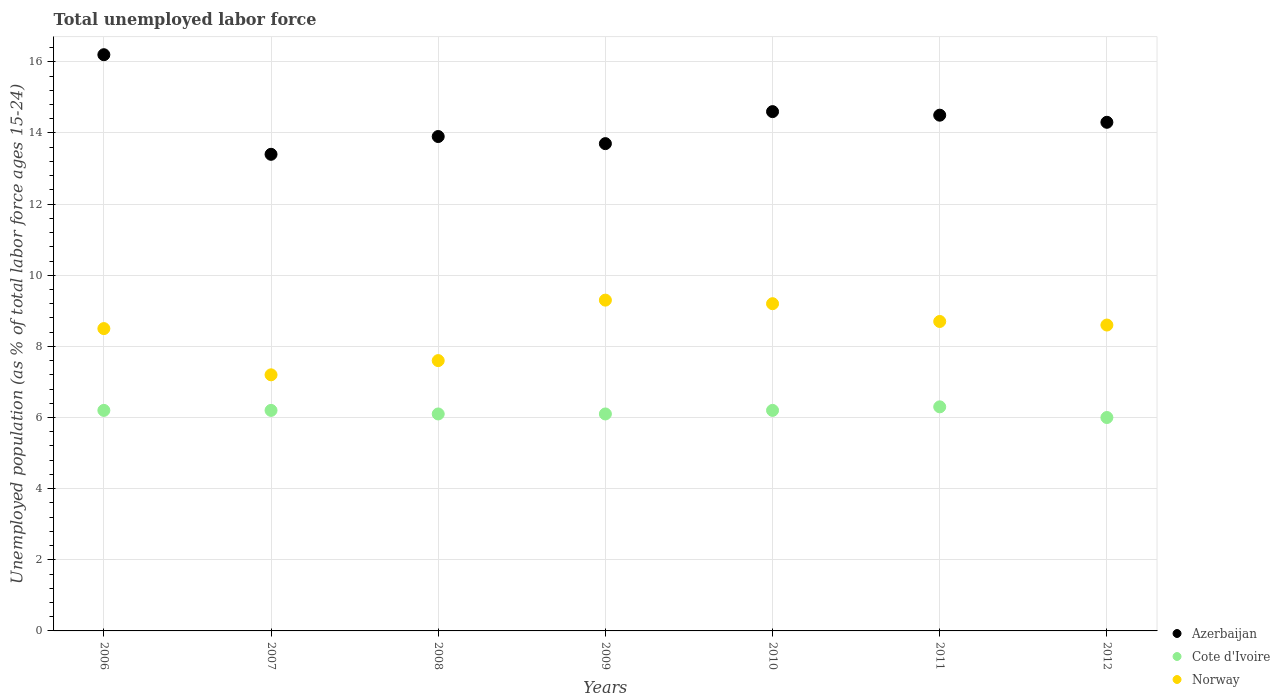Is the number of dotlines equal to the number of legend labels?
Ensure brevity in your answer.  Yes. What is the percentage of unemployed population in in Azerbaijan in 2010?
Give a very brief answer. 14.6. Across all years, what is the maximum percentage of unemployed population in in Azerbaijan?
Offer a very short reply. 16.2. Across all years, what is the minimum percentage of unemployed population in in Norway?
Ensure brevity in your answer.  7.2. In which year was the percentage of unemployed population in in Norway maximum?
Offer a very short reply. 2009. What is the total percentage of unemployed population in in Azerbaijan in the graph?
Provide a succinct answer. 100.6. What is the difference between the percentage of unemployed population in in Cote d'Ivoire in 2006 and that in 2007?
Your response must be concise. 0. What is the difference between the percentage of unemployed population in in Azerbaijan in 2011 and the percentage of unemployed population in in Norway in 2008?
Your answer should be very brief. 6.9. What is the average percentage of unemployed population in in Azerbaijan per year?
Your answer should be very brief. 14.37. In the year 2012, what is the difference between the percentage of unemployed population in in Cote d'Ivoire and percentage of unemployed population in in Norway?
Offer a terse response. -2.6. In how many years, is the percentage of unemployed population in in Norway greater than 8 %?
Provide a succinct answer. 5. What is the ratio of the percentage of unemployed population in in Cote d'Ivoire in 2007 to that in 2008?
Offer a terse response. 1.02. What is the difference between the highest and the second highest percentage of unemployed population in in Norway?
Provide a succinct answer. 0.1. What is the difference between the highest and the lowest percentage of unemployed population in in Norway?
Your answer should be very brief. 2.1. In how many years, is the percentage of unemployed population in in Norway greater than the average percentage of unemployed population in in Norway taken over all years?
Offer a very short reply. 5. How many years are there in the graph?
Provide a succinct answer. 7. What is the difference between two consecutive major ticks on the Y-axis?
Ensure brevity in your answer.  2. Are the values on the major ticks of Y-axis written in scientific E-notation?
Keep it short and to the point. No. Does the graph contain grids?
Make the answer very short. Yes. How are the legend labels stacked?
Give a very brief answer. Vertical. What is the title of the graph?
Your answer should be compact. Total unemployed labor force. What is the label or title of the Y-axis?
Give a very brief answer. Unemployed population (as % of total labor force ages 15-24). What is the Unemployed population (as % of total labor force ages 15-24) of Azerbaijan in 2006?
Your answer should be very brief. 16.2. What is the Unemployed population (as % of total labor force ages 15-24) in Cote d'Ivoire in 2006?
Offer a very short reply. 6.2. What is the Unemployed population (as % of total labor force ages 15-24) of Azerbaijan in 2007?
Provide a short and direct response. 13.4. What is the Unemployed population (as % of total labor force ages 15-24) of Cote d'Ivoire in 2007?
Provide a succinct answer. 6.2. What is the Unemployed population (as % of total labor force ages 15-24) in Norway in 2007?
Offer a terse response. 7.2. What is the Unemployed population (as % of total labor force ages 15-24) of Azerbaijan in 2008?
Make the answer very short. 13.9. What is the Unemployed population (as % of total labor force ages 15-24) in Cote d'Ivoire in 2008?
Ensure brevity in your answer.  6.1. What is the Unemployed population (as % of total labor force ages 15-24) of Norway in 2008?
Your answer should be compact. 7.6. What is the Unemployed population (as % of total labor force ages 15-24) of Azerbaijan in 2009?
Keep it short and to the point. 13.7. What is the Unemployed population (as % of total labor force ages 15-24) of Cote d'Ivoire in 2009?
Keep it short and to the point. 6.1. What is the Unemployed population (as % of total labor force ages 15-24) in Norway in 2009?
Make the answer very short. 9.3. What is the Unemployed population (as % of total labor force ages 15-24) in Azerbaijan in 2010?
Offer a very short reply. 14.6. What is the Unemployed population (as % of total labor force ages 15-24) of Cote d'Ivoire in 2010?
Keep it short and to the point. 6.2. What is the Unemployed population (as % of total labor force ages 15-24) in Norway in 2010?
Offer a very short reply. 9.2. What is the Unemployed population (as % of total labor force ages 15-24) in Azerbaijan in 2011?
Offer a very short reply. 14.5. What is the Unemployed population (as % of total labor force ages 15-24) in Cote d'Ivoire in 2011?
Your answer should be very brief. 6.3. What is the Unemployed population (as % of total labor force ages 15-24) in Norway in 2011?
Offer a terse response. 8.7. What is the Unemployed population (as % of total labor force ages 15-24) of Azerbaijan in 2012?
Ensure brevity in your answer.  14.3. What is the Unemployed population (as % of total labor force ages 15-24) of Norway in 2012?
Give a very brief answer. 8.6. Across all years, what is the maximum Unemployed population (as % of total labor force ages 15-24) in Azerbaijan?
Give a very brief answer. 16.2. Across all years, what is the maximum Unemployed population (as % of total labor force ages 15-24) of Cote d'Ivoire?
Your answer should be compact. 6.3. Across all years, what is the maximum Unemployed population (as % of total labor force ages 15-24) in Norway?
Your answer should be compact. 9.3. Across all years, what is the minimum Unemployed population (as % of total labor force ages 15-24) in Azerbaijan?
Offer a very short reply. 13.4. Across all years, what is the minimum Unemployed population (as % of total labor force ages 15-24) of Norway?
Make the answer very short. 7.2. What is the total Unemployed population (as % of total labor force ages 15-24) in Azerbaijan in the graph?
Give a very brief answer. 100.6. What is the total Unemployed population (as % of total labor force ages 15-24) in Cote d'Ivoire in the graph?
Offer a very short reply. 43.1. What is the total Unemployed population (as % of total labor force ages 15-24) in Norway in the graph?
Your response must be concise. 59.1. What is the difference between the Unemployed population (as % of total labor force ages 15-24) in Azerbaijan in 2006 and that in 2007?
Give a very brief answer. 2.8. What is the difference between the Unemployed population (as % of total labor force ages 15-24) in Cote d'Ivoire in 2006 and that in 2007?
Ensure brevity in your answer.  0. What is the difference between the Unemployed population (as % of total labor force ages 15-24) in Norway in 2006 and that in 2007?
Your answer should be compact. 1.3. What is the difference between the Unemployed population (as % of total labor force ages 15-24) of Norway in 2006 and that in 2008?
Provide a succinct answer. 0.9. What is the difference between the Unemployed population (as % of total labor force ages 15-24) of Norway in 2006 and that in 2009?
Give a very brief answer. -0.8. What is the difference between the Unemployed population (as % of total labor force ages 15-24) of Cote d'Ivoire in 2006 and that in 2010?
Offer a very short reply. 0. What is the difference between the Unemployed population (as % of total labor force ages 15-24) in Azerbaijan in 2006 and that in 2012?
Your answer should be very brief. 1.9. What is the difference between the Unemployed population (as % of total labor force ages 15-24) of Cote d'Ivoire in 2006 and that in 2012?
Your answer should be compact. 0.2. What is the difference between the Unemployed population (as % of total labor force ages 15-24) in Norway in 2007 and that in 2008?
Provide a short and direct response. -0.4. What is the difference between the Unemployed population (as % of total labor force ages 15-24) in Azerbaijan in 2007 and that in 2009?
Offer a terse response. -0.3. What is the difference between the Unemployed population (as % of total labor force ages 15-24) of Azerbaijan in 2007 and that in 2010?
Ensure brevity in your answer.  -1.2. What is the difference between the Unemployed population (as % of total labor force ages 15-24) of Cote d'Ivoire in 2007 and that in 2010?
Your response must be concise. 0. What is the difference between the Unemployed population (as % of total labor force ages 15-24) in Norway in 2007 and that in 2010?
Offer a terse response. -2. What is the difference between the Unemployed population (as % of total labor force ages 15-24) of Azerbaijan in 2007 and that in 2012?
Your answer should be very brief. -0.9. What is the difference between the Unemployed population (as % of total labor force ages 15-24) of Cote d'Ivoire in 2008 and that in 2009?
Your response must be concise. 0. What is the difference between the Unemployed population (as % of total labor force ages 15-24) of Norway in 2008 and that in 2009?
Offer a very short reply. -1.7. What is the difference between the Unemployed population (as % of total labor force ages 15-24) in Azerbaijan in 2008 and that in 2010?
Your response must be concise. -0.7. What is the difference between the Unemployed population (as % of total labor force ages 15-24) of Norway in 2008 and that in 2010?
Ensure brevity in your answer.  -1.6. What is the difference between the Unemployed population (as % of total labor force ages 15-24) in Cote d'Ivoire in 2008 and that in 2011?
Give a very brief answer. -0.2. What is the difference between the Unemployed population (as % of total labor force ages 15-24) in Azerbaijan in 2008 and that in 2012?
Keep it short and to the point. -0.4. What is the difference between the Unemployed population (as % of total labor force ages 15-24) of Norway in 2008 and that in 2012?
Provide a short and direct response. -1. What is the difference between the Unemployed population (as % of total labor force ages 15-24) in Cote d'Ivoire in 2009 and that in 2010?
Provide a succinct answer. -0.1. What is the difference between the Unemployed population (as % of total labor force ages 15-24) in Norway in 2009 and that in 2010?
Make the answer very short. 0.1. What is the difference between the Unemployed population (as % of total labor force ages 15-24) of Cote d'Ivoire in 2009 and that in 2011?
Make the answer very short. -0.2. What is the difference between the Unemployed population (as % of total labor force ages 15-24) of Norway in 2009 and that in 2011?
Offer a very short reply. 0.6. What is the difference between the Unemployed population (as % of total labor force ages 15-24) in Cote d'Ivoire in 2010 and that in 2011?
Your response must be concise. -0.1. What is the difference between the Unemployed population (as % of total labor force ages 15-24) of Norway in 2010 and that in 2011?
Give a very brief answer. 0.5. What is the difference between the Unemployed population (as % of total labor force ages 15-24) of Cote d'Ivoire in 2010 and that in 2012?
Ensure brevity in your answer.  0.2. What is the difference between the Unemployed population (as % of total labor force ages 15-24) in Norway in 2010 and that in 2012?
Keep it short and to the point. 0.6. What is the difference between the Unemployed population (as % of total labor force ages 15-24) in Cote d'Ivoire in 2011 and that in 2012?
Provide a succinct answer. 0.3. What is the difference between the Unemployed population (as % of total labor force ages 15-24) in Azerbaijan in 2006 and the Unemployed population (as % of total labor force ages 15-24) in Cote d'Ivoire in 2007?
Your answer should be very brief. 10. What is the difference between the Unemployed population (as % of total labor force ages 15-24) of Cote d'Ivoire in 2006 and the Unemployed population (as % of total labor force ages 15-24) of Norway in 2007?
Your answer should be compact. -1. What is the difference between the Unemployed population (as % of total labor force ages 15-24) in Azerbaijan in 2006 and the Unemployed population (as % of total labor force ages 15-24) in Cote d'Ivoire in 2008?
Your answer should be compact. 10.1. What is the difference between the Unemployed population (as % of total labor force ages 15-24) of Azerbaijan in 2006 and the Unemployed population (as % of total labor force ages 15-24) of Norway in 2008?
Your response must be concise. 8.6. What is the difference between the Unemployed population (as % of total labor force ages 15-24) of Cote d'Ivoire in 2006 and the Unemployed population (as % of total labor force ages 15-24) of Norway in 2008?
Give a very brief answer. -1.4. What is the difference between the Unemployed population (as % of total labor force ages 15-24) in Azerbaijan in 2006 and the Unemployed population (as % of total labor force ages 15-24) in Cote d'Ivoire in 2009?
Your answer should be compact. 10.1. What is the difference between the Unemployed population (as % of total labor force ages 15-24) of Azerbaijan in 2006 and the Unemployed population (as % of total labor force ages 15-24) of Norway in 2009?
Keep it short and to the point. 6.9. What is the difference between the Unemployed population (as % of total labor force ages 15-24) in Cote d'Ivoire in 2006 and the Unemployed population (as % of total labor force ages 15-24) in Norway in 2009?
Provide a short and direct response. -3.1. What is the difference between the Unemployed population (as % of total labor force ages 15-24) in Azerbaijan in 2006 and the Unemployed population (as % of total labor force ages 15-24) in Cote d'Ivoire in 2010?
Ensure brevity in your answer.  10. What is the difference between the Unemployed population (as % of total labor force ages 15-24) of Azerbaijan in 2006 and the Unemployed population (as % of total labor force ages 15-24) of Norway in 2011?
Your answer should be compact. 7.5. What is the difference between the Unemployed population (as % of total labor force ages 15-24) in Azerbaijan in 2006 and the Unemployed population (as % of total labor force ages 15-24) in Norway in 2012?
Make the answer very short. 7.6. What is the difference between the Unemployed population (as % of total labor force ages 15-24) in Azerbaijan in 2007 and the Unemployed population (as % of total labor force ages 15-24) in Cote d'Ivoire in 2008?
Make the answer very short. 7.3. What is the difference between the Unemployed population (as % of total labor force ages 15-24) in Cote d'Ivoire in 2007 and the Unemployed population (as % of total labor force ages 15-24) in Norway in 2008?
Provide a succinct answer. -1.4. What is the difference between the Unemployed population (as % of total labor force ages 15-24) in Azerbaijan in 2007 and the Unemployed population (as % of total labor force ages 15-24) in Cote d'Ivoire in 2009?
Your response must be concise. 7.3. What is the difference between the Unemployed population (as % of total labor force ages 15-24) of Azerbaijan in 2007 and the Unemployed population (as % of total labor force ages 15-24) of Norway in 2010?
Your answer should be very brief. 4.2. What is the difference between the Unemployed population (as % of total labor force ages 15-24) of Cote d'Ivoire in 2007 and the Unemployed population (as % of total labor force ages 15-24) of Norway in 2011?
Keep it short and to the point. -2.5. What is the difference between the Unemployed population (as % of total labor force ages 15-24) of Azerbaijan in 2007 and the Unemployed population (as % of total labor force ages 15-24) of Norway in 2012?
Provide a succinct answer. 4.8. What is the difference between the Unemployed population (as % of total labor force ages 15-24) of Azerbaijan in 2008 and the Unemployed population (as % of total labor force ages 15-24) of Cote d'Ivoire in 2009?
Your answer should be very brief. 7.8. What is the difference between the Unemployed population (as % of total labor force ages 15-24) in Azerbaijan in 2008 and the Unemployed population (as % of total labor force ages 15-24) in Norway in 2009?
Keep it short and to the point. 4.6. What is the difference between the Unemployed population (as % of total labor force ages 15-24) in Azerbaijan in 2008 and the Unemployed population (as % of total labor force ages 15-24) in Norway in 2010?
Offer a terse response. 4.7. What is the difference between the Unemployed population (as % of total labor force ages 15-24) in Cote d'Ivoire in 2008 and the Unemployed population (as % of total labor force ages 15-24) in Norway in 2011?
Offer a very short reply. -2.6. What is the difference between the Unemployed population (as % of total labor force ages 15-24) in Cote d'Ivoire in 2008 and the Unemployed population (as % of total labor force ages 15-24) in Norway in 2012?
Offer a very short reply. -2.5. What is the difference between the Unemployed population (as % of total labor force ages 15-24) in Cote d'Ivoire in 2009 and the Unemployed population (as % of total labor force ages 15-24) in Norway in 2010?
Make the answer very short. -3.1. What is the difference between the Unemployed population (as % of total labor force ages 15-24) of Azerbaijan in 2009 and the Unemployed population (as % of total labor force ages 15-24) of Norway in 2011?
Offer a very short reply. 5. What is the difference between the Unemployed population (as % of total labor force ages 15-24) in Cote d'Ivoire in 2009 and the Unemployed population (as % of total labor force ages 15-24) in Norway in 2011?
Your response must be concise. -2.6. What is the difference between the Unemployed population (as % of total labor force ages 15-24) of Azerbaijan in 2009 and the Unemployed population (as % of total labor force ages 15-24) of Cote d'Ivoire in 2012?
Provide a short and direct response. 7.7. What is the difference between the Unemployed population (as % of total labor force ages 15-24) of Cote d'Ivoire in 2010 and the Unemployed population (as % of total labor force ages 15-24) of Norway in 2012?
Provide a succinct answer. -2.4. What is the difference between the Unemployed population (as % of total labor force ages 15-24) in Azerbaijan in 2011 and the Unemployed population (as % of total labor force ages 15-24) in Cote d'Ivoire in 2012?
Keep it short and to the point. 8.5. What is the average Unemployed population (as % of total labor force ages 15-24) in Azerbaijan per year?
Ensure brevity in your answer.  14.37. What is the average Unemployed population (as % of total labor force ages 15-24) of Cote d'Ivoire per year?
Your response must be concise. 6.16. What is the average Unemployed population (as % of total labor force ages 15-24) in Norway per year?
Provide a short and direct response. 8.44. In the year 2006, what is the difference between the Unemployed population (as % of total labor force ages 15-24) of Azerbaijan and Unemployed population (as % of total labor force ages 15-24) of Cote d'Ivoire?
Your answer should be compact. 10. In the year 2006, what is the difference between the Unemployed population (as % of total labor force ages 15-24) of Cote d'Ivoire and Unemployed population (as % of total labor force ages 15-24) of Norway?
Your answer should be very brief. -2.3. In the year 2007, what is the difference between the Unemployed population (as % of total labor force ages 15-24) in Azerbaijan and Unemployed population (as % of total labor force ages 15-24) in Norway?
Provide a succinct answer. 6.2. In the year 2007, what is the difference between the Unemployed population (as % of total labor force ages 15-24) in Cote d'Ivoire and Unemployed population (as % of total labor force ages 15-24) in Norway?
Your response must be concise. -1. In the year 2009, what is the difference between the Unemployed population (as % of total labor force ages 15-24) of Azerbaijan and Unemployed population (as % of total labor force ages 15-24) of Cote d'Ivoire?
Give a very brief answer. 7.6. In the year 2009, what is the difference between the Unemployed population (as % of total labor force ages 15-24) of Azerbaijan and Unemployed population (as % of total labor force ages 15-24) of Norway?
Your answer should be very brief. 4.4. In the year 2010, what is the difference between the Unemployed population (as % of total labor force ages 15-24) of Azerbaijan and Unemployed population (as % of total labor force ages 15-24) of Cote d'Ivoire?
Give a very brief answer. 8.4. In the year 2010, what is the difference between the Unemployed population (as % of total labor force ages 15-24) of Azerbaijan and Unemployed population (as % of total labor force ages 15-24) of Norway?
Offer a terse response. 5.4. In the year 2011, what is the difference between the Unemployed population (as % of total labor force ages 15-24) in Azerbaijan and Unemployed population (as % of total labor force ages 15-24) in Cote d'Ivoire?
Give a very brief answer. 8.2. In the year 2011, what is the difference between the Unemployed population (as % of total labor force ages 15-24) in Azerbaijan and Unemployed population (as % of total labor force ages 15-24) in Norway?
Keep it short and to the point. 5.8. In the year 2011, what is the difference between the Unemployed population (as % of total labor force ages 15-24) in Cote d'Ivoire and Unemployed population (as % of total labor force ages 15-24) in Norway?
Your answer should be very brief. -2.4. In the year 2012, what is the difference between the Unemployed population (as % of total labor force ages 15-24) of Azerbaijan and Unemployed population (as % of total labor force ages 15-24) of Norway?
Your response must be concise. 5.7. In the year 2012, what is the difference between the Unemployed population (as % of total labor force ages 15-24) of Cote d'Ivoire and Unemployed population (as % of total labor force ages 15-24) of Norway?
Offer a terse response. -2.6. What is the ratio of the Unemployed population (as % of total labor force ages 15-24) of Azerbaijan in 2006 to that in 2007?
Make the answer very short. 1.21. What is the ratio of the Unemployed population (as % of total labor force ages 15-24) of Cote d'Ivoire in 2006 to that in 2007?
Offer a terse response. 1. What is the ratio of the Unemployed population (as % of total labor force ages 15-24) of Norway in 2006 to that in 2007?
Ensure brevity in your answer.  1.18. What is the ratio of the Unemployed population (as % of total labor force ages 15-24) of Azerbaijan in 2006 to that in 2008?
Offer a terse response. 1.17. What is the ratio of the Unemployed population (as % of total labor force ages 15-24) in Cote d'Ivoire in 2006 to that in 2008?
Offer a very short reply. 1.02. What is the ratio of the Unemployed population (as % of total labor force ages 15-24) of Norway in 2006 to that in 2008?
Make the answer very short. 1.12. What is the ratio of the Unemployed population (as % of total labor force ages 15-24) in Azerbaijan in 2006 to that in 2009?
Make the answer very short. 1.18. What is the ratio of the Unemployed population (as % of total labor force ages 15-24) in Cote d'Ivoire in 2006 to that in 2009?
Your answer should be very brief. 1.02. What is the ratio of the Unemployed population (as % of total labor force ages 15-24) in Norway in 2006 to that in 2009?
Provide a short and direct response. 0.91. What is the ratio of the Unemployed population (as % of total labor force ages 15-24) of Azerbaijan in 2006 to that in 2010?
Offer a very short reply. 1.11. What is the ratio of the Unemployed population (as % of total labor force ages 15-24) of Norway in 2006 to that in 2010?
Ensure brevity in your answer.  0.92. What is the ratio of the Unemployed population (as % of total labor force ages 15-24) in Azerbaijan in 2006 to that in 2011?
Your answer should be very brief. 1.12. What is the ratio of the Unemployed population (as % of total labor force ages 15-24) of Cote d'Ivoire in 2006 to that in 2011?
Give a very brief answer. 0.98. What is the ratio of the Unemployed population (as % of total labor force ages 15-24) in Norway in 2006 to that in 2011?
Your answer should be compact. 0.98. What is the ratio of the Unemployed population (as % of total labor force ages 15-24) of Azerbaijan in 2006 to that in 2012?
Keep it short and to the point. 1.13. What is the ratio of the Unemployed population (as % of total labor force ages 15-24) in Cote d'Ivoire in 2006 to that in 2012?
Provide a short and direct response. 1.03. What is the ratio of the Unemployed population (as % of total labor force ages 15-24) in Norway in 2006 to that in 2012?
Provide a succinct answer. 0.99. What is the ratio of the Unemployed population (as % of total labor force ages 15-24) in Cote d'Ivoire in 2007 to that in 2008?
Your response must be concise. 1.02. What is the ratio of the Unemployed population (as % of total labor force ages 15-24) of Azerbaijan in 2007 to that in 2009?
Offer a terse response. 0.98. What is the ratio of the Unemployed population (as % of total labor force ages 15-24) in Cote d'Ivoire in 2007 to that in 2009?
Ensure brevity in your answer.  1.02. What is the ratio of the Unemployed population (as % of total labor force ages 15-24) in Norway in 2007 to that in 2009?
Ensure brevity in your answer.  0.77. What is the ratio of the Unemployed population (as % of total labor force ages 15-24) of Azerbaijan in 2007 to that in 2010?
Give a very brief answer. 0.92. What is the ratio of the Unemployed population (as % of total labor force ages 15-24) of Cote d'Ivoire in 2007 to that in 2010?
Offer a very short reply. 1. What is the ratio of the Unemployed population (as % of total labor force ages 15-24) in Norway in 2007 to that in 2010?
Keep it short and to the point. 0.78. What is the ratio of the Unemployed population (as % of total labor force ages 15-24) in Azerbaijan in 2007 to that in 2011?
Your response must be concise. 0.92. What is the ratio of the Unemployed population (as % of total labor force ages 15-24) in Cote d'Ivoire in 2007 to that in 2011?
Provide a short and direct response. 0.98. What is the ratio of the Unemployed population (as % of total labor force ages 15-24) in Norway in 2007 to that in 2011?
Provide a succinct answer. 0.83. What is the ratio of the Unemployed population (as % of total labor force ages 15-24) in Azerbaijan in 2007 to that in 2012?
Offer a very short reply. 0.94. What is the ratio of the Unemployed population (as % of total labor force ages 15-24) in Norway in 2007 to that in 2012?
Your response must be concise. 0.84. What is the ratio of the Unemployed population (as % of total labor force ages 15-24) of Azerbaijan in 2008 to that in 2009?
Make the answer very short. 1.01. What is the ratio of the Unemployed population (as % of total labor force ages 15-24) in Cote d'Ivoire in 2008 to that in 2009?
Provide a short and direct response. 1. What is the ratio of the Unemployed population (as % of total labor force ages 15-24) of Norway in 2008 to that in 2009?
Keep it short and to the point. 0.82. What is the ratio of the Unemployed population (as % of total labor force ages 15-24) of Azerbaijan in 2008 to that in 2010?
Provide a short and direct response. 0.95. What is the ratio of the Unemployed population (as % of total labor force ages 15-24) in Cote d'Ivoire in 2008 to that in 2010?
Ensure brevity in your answer.  0.98. What is the ratio of the Unemployed population (as % of total labor force ages 15-24) in Norway in 2008 to that in 2010?
Your answer should be very brief. 0.83. What is the ratio of the Unemployed population (as % of total labor force ages 15-24) of Azerbaijan in 2008 to that in 2011?
Offer a very short reply. 0.96. What is the ratio of the Unemployed population (as % of total labor force ages 15-24) in Cote d'Ivoire in 2008 to that in 2011?
Provide a short and direct response. 0.97. What is the ratio of the Unemployed population (as % of total labor force ages 15-24) of Norway in 2008 to that in 2011?
Your answer should be compact. 0.87. What is the ratio of the Unemployed population (as % of total labor force ages 15-24) in Cote d'Ivoire in 2008 to that in 2012?
Your answer should be compact. 1.02. What is the ratio of the Unemployed population (as % of total labor force ages 15-24) in Norway in 2008 to that in 2012?
Provide a short and direct response. 0.88. What is the ratio of the Unemployed population (as % of total labor force ages 15-24) in Azerbaijan in 2009 to that in 2010?
Keep it short and to the point. 0.94. What is the ratio of the Unemployed population (as % of total labor force ages 15-24) of Cote d'Ivoire in 2009 to that in 2010?
Your answer should be very brief. 0.98. What is the ratio of the Unemployed population (as % of total labor force ages 15-24) of Norway in 2009 to that in 2010?
Your response must be concise. 1.01. What is the ratio of the Unemployed population (as % of total labor force ages 15-24) of Azerbaijan in 2009 to that in 2011?
Your response must be concise. 0.94. What is the ratio of the Unemployed population (as % of total labor force ages 15-24) in Cote d'Ivoire in 2009 to that in 2011?
Ensure brevity in your answer.  0.97. What is the ratio of the Unemployed population (as % of total labor force ages 15-24) of Norway in 2009 to that in 2011?
Ensure brevity in your answer.  1.07. What is the ratio of the Unemployed population (as % of total labor force ages 15-24) in Azerbaijan in 2009 to that in 2012?
Provide a short and direct response. 0.96. What is the ratio of the Unemployed population (as % of total labor force ages 15-24) in Cote d'Ivoire in 2009 to that in 2012?
Offer a terse response. 1.02. What is the ratio of the Unemployed population (as % of total labor force ages 15-24) in Norway in 2009 to that in 2012?
Keep it short and to the point. 1.08. What is the ratio of the Unemployed population (as % of total labor force ages 15-24) of Cote d'Ivoire in 2010 to that in 2011?
Offer a very short reply. 0.98. What is the ratio of the Unemployed population (as % of total labor force ages 15-24) in Norway in 2010 to that in 2011?
Keep it short and to the point. 1.06. What is the ratio of the Unemployed population (as % of total labor force ages 15-24) in Norway in 2010 to that in 2012?
Keep it short and to the point. 1.07. What is the ratio of the Unemployed population (as % of total labor force ages 15-24) in Azerbaijan in 2011 to that in 2012?
Provide a short and direct response. 1.01. What is the ratio of the Unemployed population (as % of total labor force ages 15-24) of Norway in 2011 to that in 2012?
Your answer should be very brief. 1.01. What is the difference between the highest and the second highest Unemployed population (as % of total labor force ages 15-24) in Cote d'Ivoire?
Provide a short and direct response. 0.1. What is the difference between the highest and the second highest Unemployed population (as % of total labor force ages 15-24) in Norway?
Your response must be concise. 0.1. What is the difference between the highest and the lowest Unemployed population (as % of total labor force ages 15-24) of Cote d'Ivoire?
Your answer should be compact. 0.3. What is the difference between the highest and the lowest Unemployed population (as % of total labor force ages 15-24) of Norway?
Your response must be concise. 2.1. 